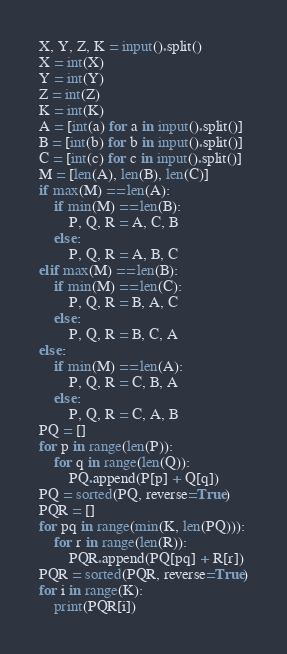<code> <loc_0><loc_0><loc_500><loc_500><_Python_>X, Y, Z, K = input().split()
X = int(X)
Y = int(Y)
Z = int(Z)
K = int(K)
A = [int(a) for a in input().split()]
B = [int(b) for b in input().split()]
C = [int(c) for c in input().split()]
M = [len(A), len(B), len(C)]
if max(M) == len(A):
    if min(M) == len(B):
        P, Q, R = A, C, B
    else:
        P, Q, R = A, B, C
elif max(M) == len(B):
    if min(M) == len(C):
        P, Q, R = B, A, C
    else:
        P, Q, R = B, C, A
else:
    if min(M) == len(A):
        P, Q, R = C, B, A
    else:
        P, Q, R = C, A, B
PQ = []
for p in range(len(P)):
    for q in range(len(Q)):
        PQ.append(P[p] + Q[q])
PQ = sorted(PQ, reverse=True)
PQR = []
for pq in range(min(K, len(PQ))):
    for r in range(len(R)):
        PQR.append(PQ[pq] + R[r])
PQR = sorted(PQR, reverse=True)
for i in range(K):
    print(PQR[i])</code> 